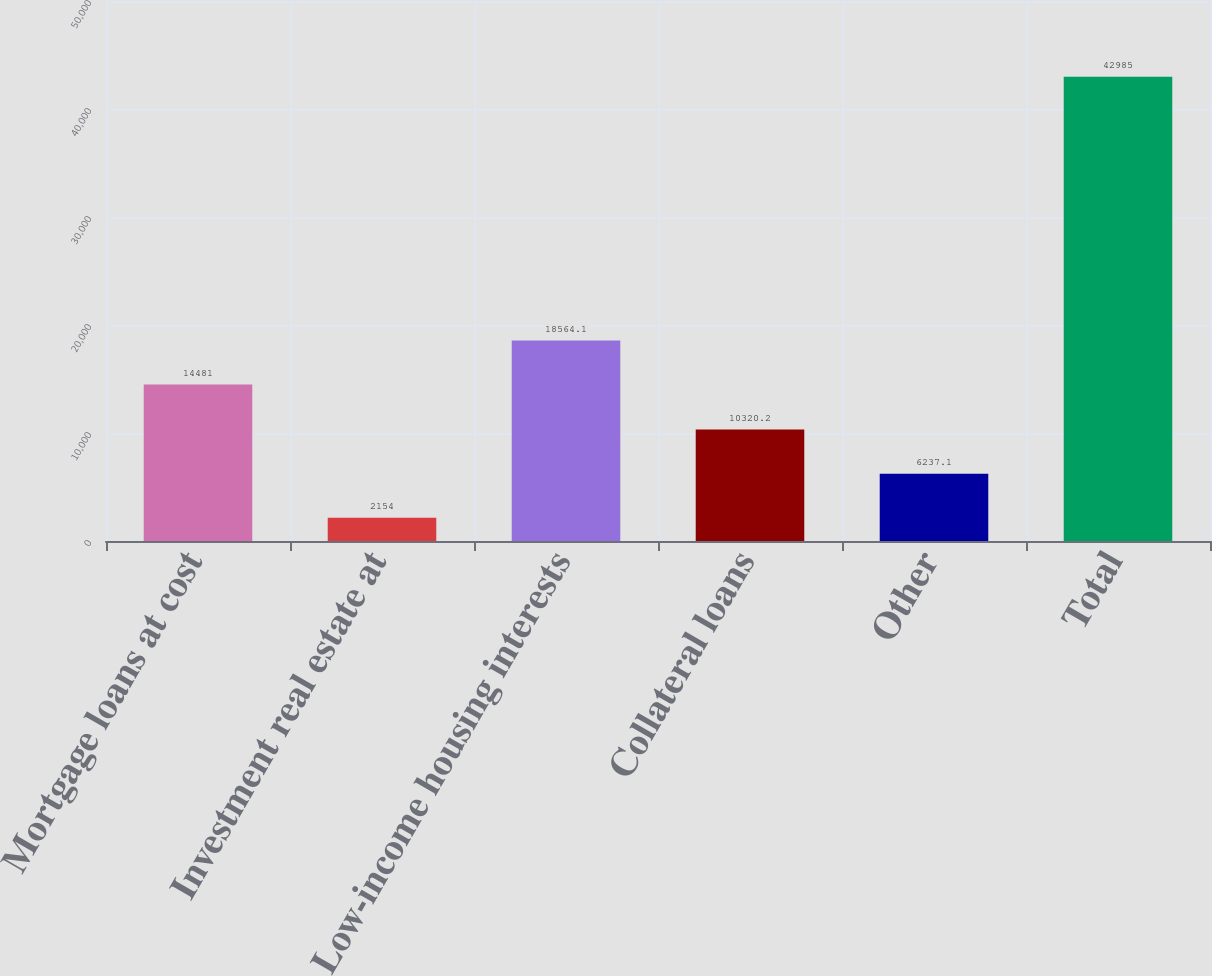<chart> <loc_0><loc_0><loc_500><loc_500><bar_chart><fcel>Mortgage loans at cost<fcel>Investment real estate at<fcel>Low-income housing interests<fcel>Collateral loans<fcel>Other<fcel>Total<nl><fcel>14481<fcel>2154<fcel>18564.1<fcel>10320.2<fcel>6237.1<fcel>42985<nl></chart> 